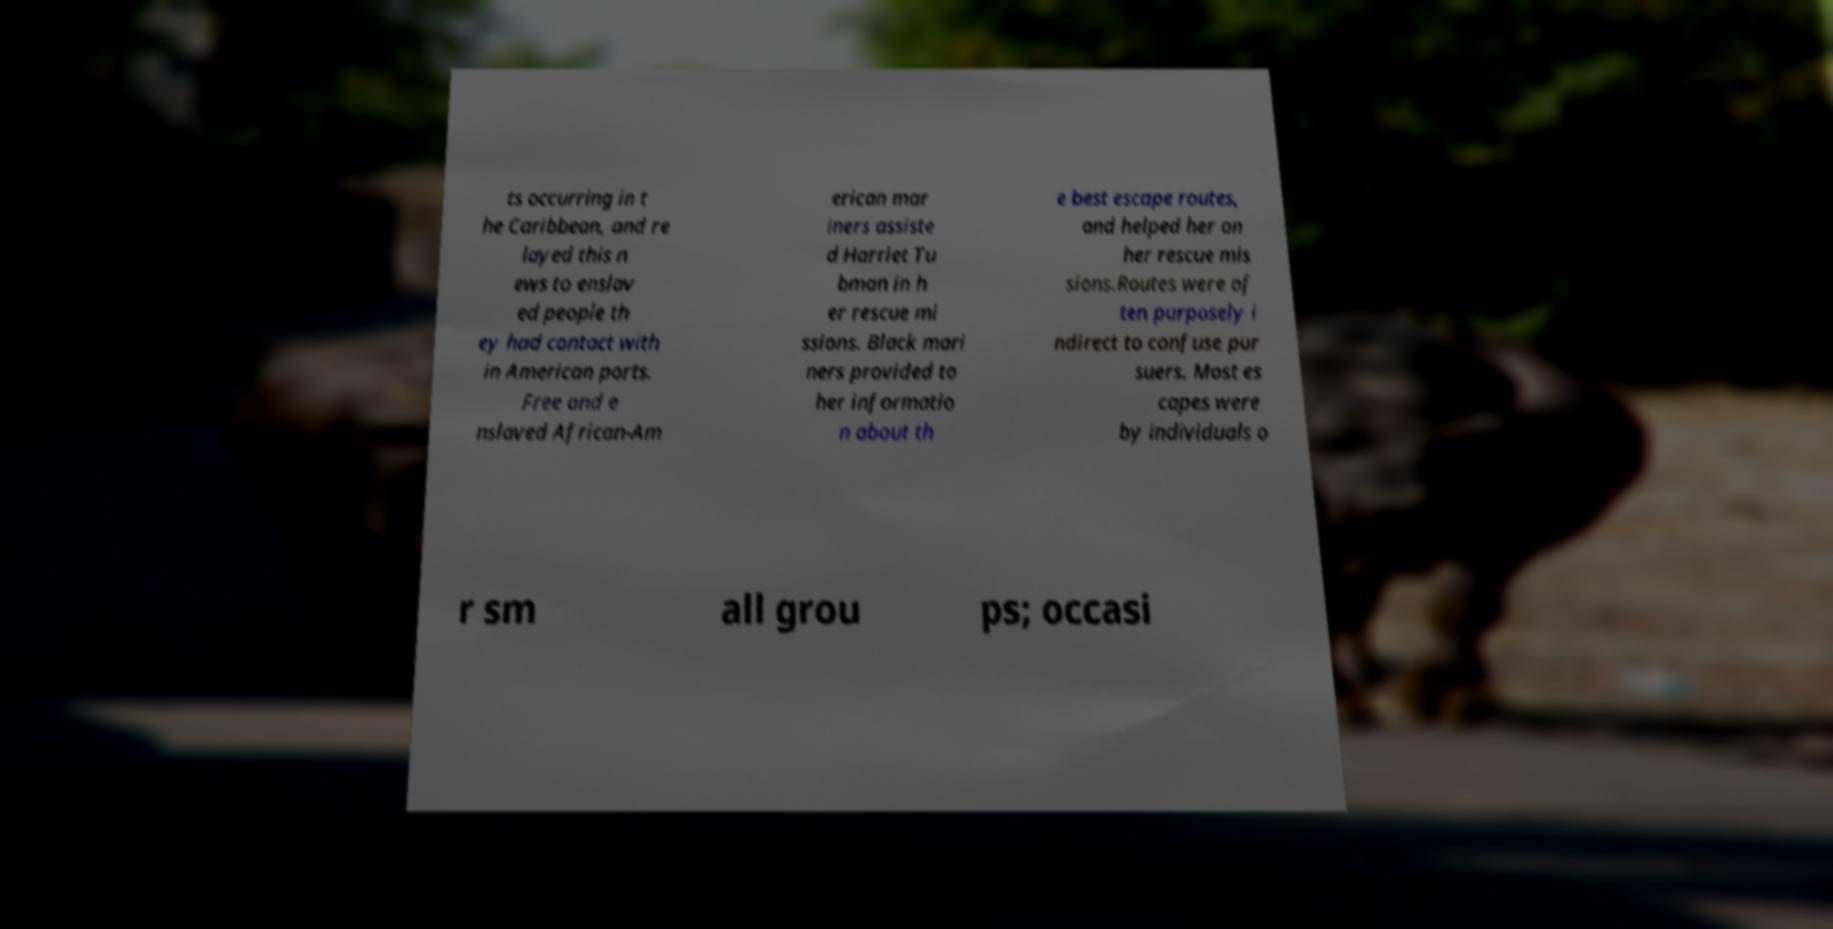Please read and relay the text visible in this image. What does it say? ts occurring in t he Caribbean, and re layed this n ews to enslav ed people th ey had contact with in American ports. Free and e nslaved African-Am erican mar iners assiste d Harriet Tu bman in h er rescue mi ssions. Black mari ners provided to her informatio n about th e best escape routes, and helped her on her rescue mis sions.Routes were of ten purposely i ndirect to confuse pur suers. Most es capes were by individuals o r sm all grou ps; occasi 